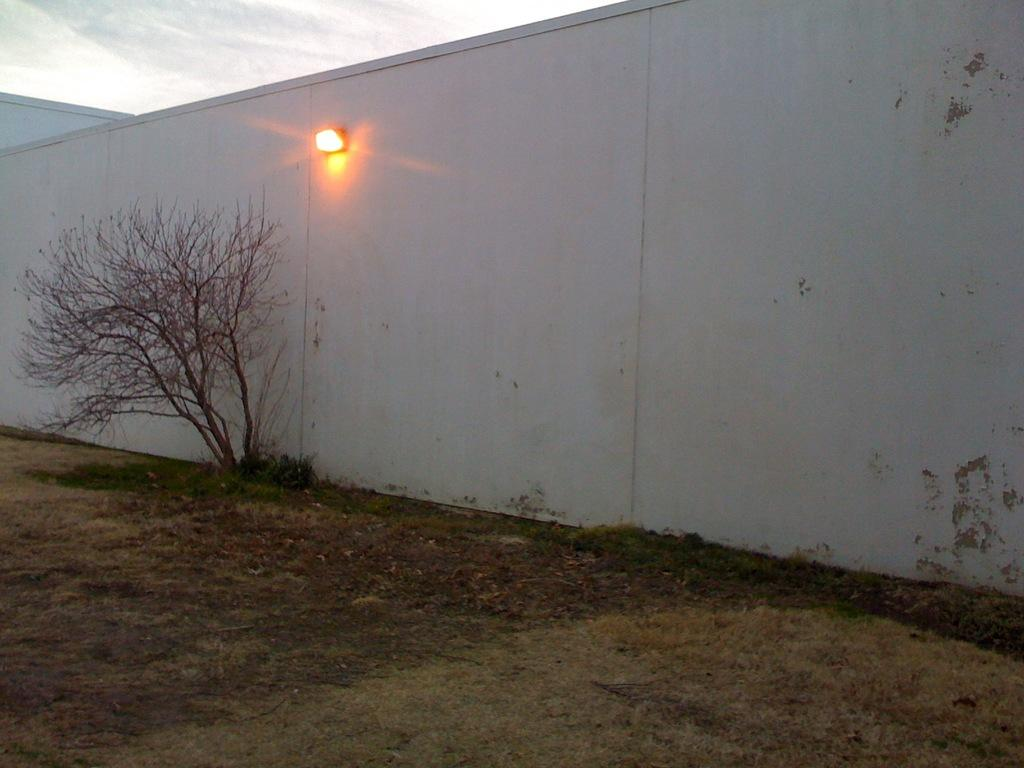What type of vegetation is present in the image? There are plants and grass in the image. Where are the plants and grass located? The plants and grass are on the ground in the image. What can be seen on the wall in the image? There is a light on the wall in the image. What is visible in the sky in the background of the image? There are clouds in the sky in the background of the image. What type of health advice can be seen on the wall in the image? There is no health advice visible on the wall in the image; it only features a light. Can you see a woman interacting with the plants in the image? There is no woman present in the image; it only features plants, grass, a wall, a light, and clouds in the sky. 